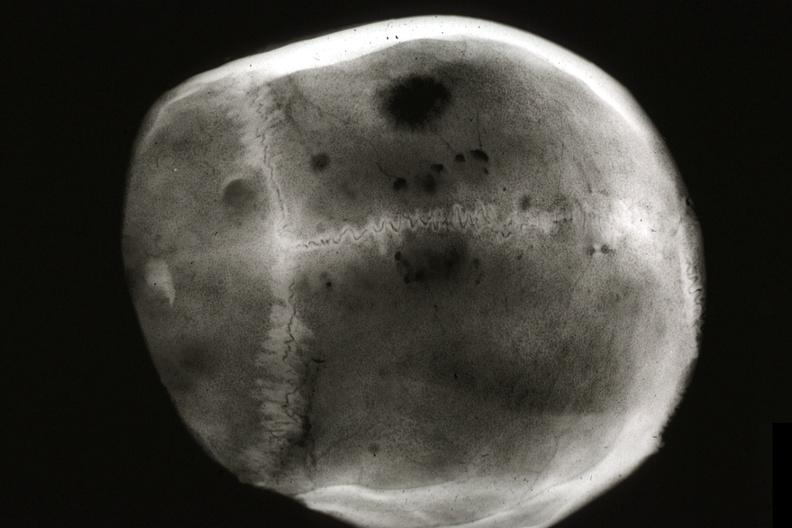does this image show x-ray skull cap multiple lytic lesions prostate adenocarcinoma?
Answer the question using a single word or phrase. Yes 